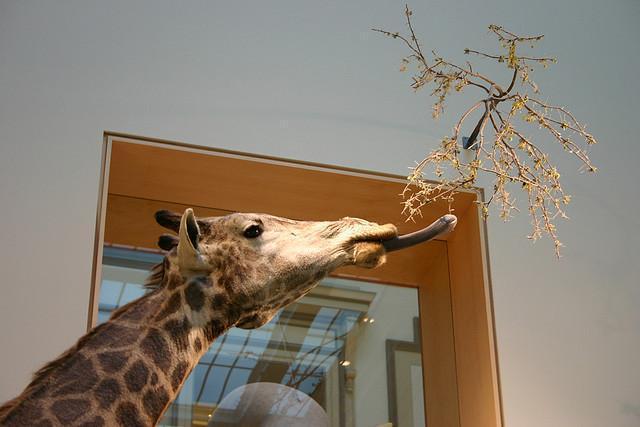How many giraffes are there?
Give a very brief answer. 1. 